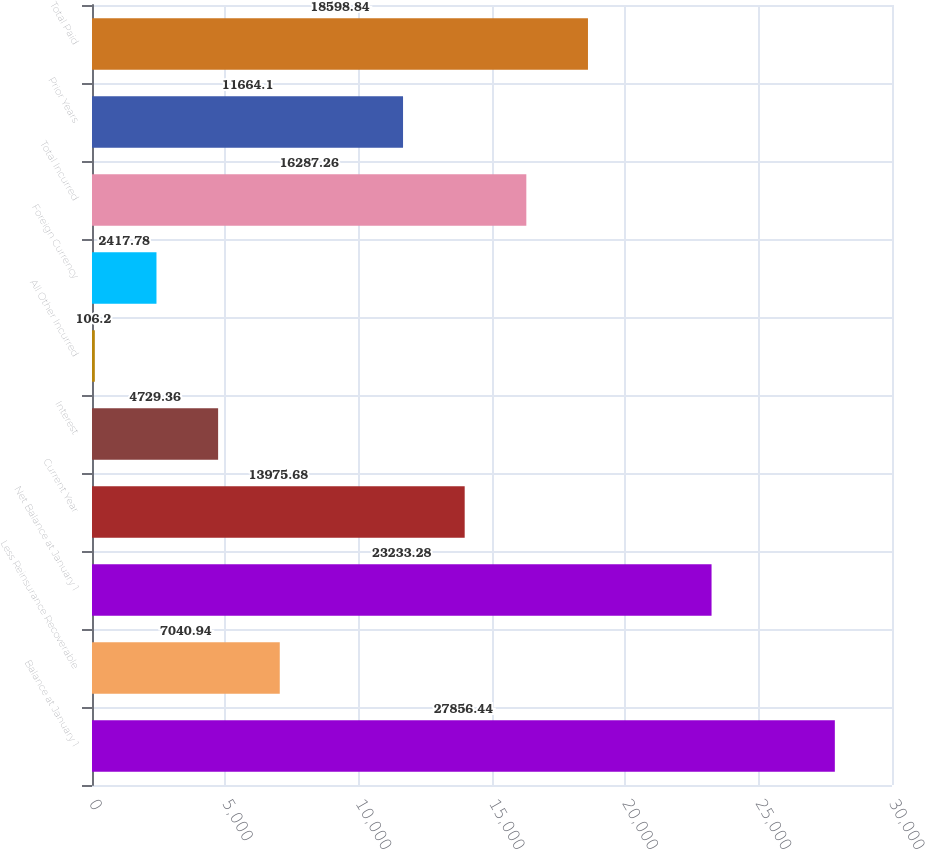Convert chart. <chart><loc_0><loc_0><loc_500><loc_500><bar_chart><fcel>Balance at January 1<fcel>Less Reinsurance Recoverable<fcel>Net Balance at January 1<fcel>Current Year<fcel>Interest<fcel>All Other Incurred<fcel>Foreign Currency<fcel>Total Incurred<fcel>Prior Years<fcel>Total Paid<nl><fcel>27856.4<fcel>7040.94<fcel>23233.3<fcel>13975.7<fcel>4729.36<fcel>106.2<fcel>2417.78<fcel>16287.3<fcel>11664.1<fcel>18598.8<nl></chart> 